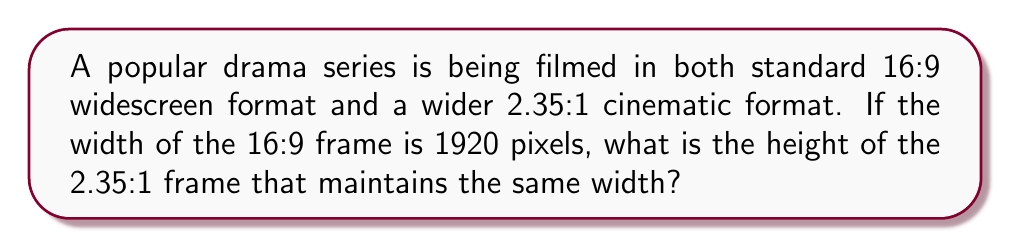Give your solution to this math problem. Let's approach this step-by-step:

1) First, we need to understand what aspect ratio means. It's the ratio of width to height.

2) For the 16:9 format:
   $\frac{\text{width}}{\text{height}} = \frac{16}{9}$

3) We're given that the width is 1920 pixels. Let's find the height:
   $\frac{1920}{\text{height}} = \frac{16}{9}$

4) Cross multiply:
   $9 \times 1920 = 16 \times \text{height}$

5) Solve for height:
   $\text{height} = \frac{9 \times 1920}{16} = 1080$ pixels

6) Now, for the 2.35:1 format:
   $\frac{\text{width}}{\text{height}} = \frac{2.35}{1}$

7) We want to keep the same width (1920 pixels). Let's call the new height $h$:
   $\frac{1920}{h} = \frac{2.35}{1}$

8) Cross multiply:
   $1 \times 1920 = 2.35 \times h$

9) Solve for $h$:
   $h = \frac{1920}{2.35} \approx 817.02$ pixels

10) Round to the nearest whole pixel:
    $h = 817$ pixels
Answer: 817 pixels 